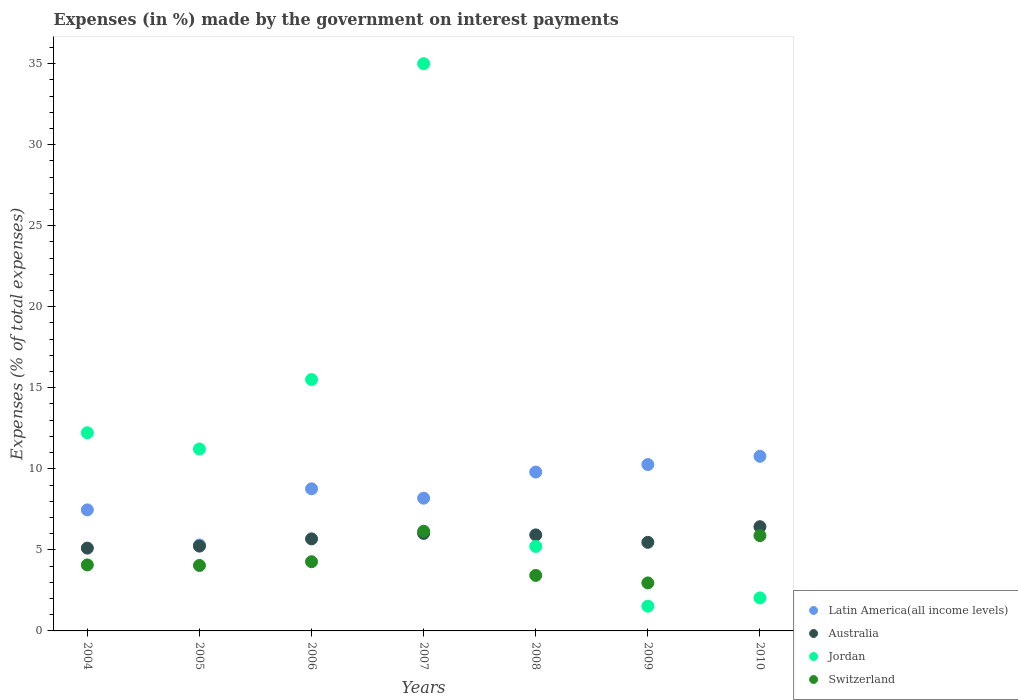How many different coloured dotlines are there?
Offer a very short reply. 4. What is the percentage of expenses made by the government on interest payments in Jordan in 2005?
Ensure brevity in your answer.  11.22. Across all years, what is the maximum percentage of expenses made by the government on interest payments in Switzerland?
Provide a short and direct response. 6.15. Across all years, what is the minimum percentage of expenses made by the government on interest payments in Jordan?
Your response must be concise. 1.52. In which year was the percentage of expenses made by the government on interest payments in Latin America(all income levels) maximum?
Your response must be concise. 2010. In which year was the percentage of expenses made by the government on interest payments in Latin America(all income levels) minimum?
Make the answer very short. 2005. What is the total percentage of expenses made by the government on interest payments in Switzerland in the graph?
Ensure brevity in your answer.  30.79. What is the difference between the percentage of expenses made by the government on interest payments in Switzerland in 2009 and that in 2010?
Your response must be concise. -2.92. What is the difference between the percentage of expenses made by the government on interest payments in Jordan in 2005 and the percentage of expenses made by the government on interest payments in Australia in 2009?
Your answer should be compact. 5.76. What is the average percentage of expenses made by the government on interest payments in Jordan per year?
Keep it short and to the point. 11.82. In the year 2010, what is the difference between the percentage of expenses made by the government on interest payments in Latin America(all income levels) and percentage of expenses made by the government on interest payments in Australia?
Give a very brief answer. 4.34. In how many years, is the percentage of expenses made by the government on interest payments in Australia greater than 7 %?
Give a very brief answer. 0. What is the ratio of the percentage of expenses made by the government on interest payments in Latin America(all income levels) in 2007 to that in 2008?
Offer a terse response. 0.84. Is the percentage of expenses made by the government on interest payments in Jordan in 2006 less than that in 2007?
Ensure brevity in your answer.  Yes. What is the difference between the highest and the second highest percentage of expenses made by the government on interest payments in Latin America(all income levels)?
Offer a terse response. 0.51. What is the difference between the highest and the lowest percentage of expenses made by the government on interest payments in Australia?
Give a very brief answer. 1.32. Is it the case that in every year, the sum of the percentage of expenses made by the government on interest payments in Jordan and percentage of expenses made by the government on interest payments in Switzerland  is greater than the sum of percentage of expenses made by the government on interest payments in Australia and percentage of expenses made by the government on interest payments in Latin America(all income levels)?
Give a very brief answer. No. Is the percentage of expenses made by the government on interest payments in Switzerland strictly greater than the percentage of expenses made by the government on interest payments in Australia over the years?
Keep it short and to the point. No. How many dotlines are there?
Your answer should be compact. 4. What is the difference between two consecutive major ticks on the Y-axis?
Your answer should be very brief. 5. Does the graph contain any zero values?
Keep it short and to the point. No. Does the graph contain grids?
Keep it short and to the point. No. How many legend labels are there?
Offer a terse response. 4. What is the title of the graph?
Give a very brief answer. Expenses (in %) made by the government on interest payments. Does "Lebanon" appear as one of the legend labels in the graph?
Keep it short and to the point. No. What is the label or title of the Y-axis?
Offer a terse response. Expenses (% of total expenses). What is the Expenses (% of total expenses) of Latin America(all income levels) in 2004?
Ensure brevity in your answer.  7.47. What is the Expenses (% of total expenses) of Australia in 2004?
Keep it short and to the point. 5.11. What is the Expenses (% of total expenses) of Jordan in 2004?
Provide a short and direct response. 12.22. What is the Expenses (% of total expenses) in Switzerland in 2004?
Give a very brief answer. 4.07. What is the Expenses (% of total expenses) in Latin America(all income levels) in 2005?
Keep it short and to the point. 5.3. What is the Expenses (% of total expenses) of Australia in 2005?
Your answer should be very brief. 5.23. What is the Expenses (% of total expenses) of Jordan in 2005?
Offer a very short reply. 11.22. What is the Expenses (% of total expenses) in Switzerland in 2005?
Offer a terse response. 4.04. What is the Expenses (% of total expenses) in Latin America(all income levels) in 2006?
Your answer should be compact. 8.77. What is the Expenses (% of total expenses) in Australia in 2006?
Offer a terse response. 5.68. What is the Expenses (% of total expenses) in Jordan in 2006?
Your response must be concise. 15.51. What is the Expenses (% of total expenses) of Switzerland in 2006?
Provide a short and direct response. 4.27. What is the Expenses (% of total expenses) in Latin America(all income levels) in 2007?
Provide a succinct answer. 8.19. What is the Expenses (% of total expenses) of Australia in 2007?
Ensure brevity in your answer.  6.02. What is the Expenses (% of total expenses) in Jordan in 2007?
Your answer should be compact. 34.99. What is the Expenses (% of total expenses) of Switzerland in 2007?
Provide a short and direct response. 6.15. What is the Expenses (% of total expenses) of Latin America(all income levels) in 2008?
Offer a terse response. 9.8. What is the Expenses (% of total expenses) in Australia in 2008?
Give a very brief answer. 5.92. What is the Expenses (% of total expenses) of Jordan in 2008?
Give a very brief answer. 5.21. What is the Expenses (% of total expenses) in Switzerland in 2008?
Your answer should be very brief. 3.42. What is the Expenses (% of total expenses) of Latin America(all income levels) in 2009?
Your response must be concise. 10.26. What is the Expenses (% of total expenses) of Australia in 2009?
Your response must be concise. 5.47. What is the Expenses (% of total expenses) in Jordan in 2009?
Your response must be concise. 1.52. What is the Expenses (% of total expenses) in Switzerland in 2009?
Offer a terse response. 2.96. What is the Expenses (% of total expenses) of Latin America(all income levels) in 2010?
Provide a short and direct response. 10.77. What is the Expenses (% of total expenses) in Australia in 2010?
Keep it short and to the point. 6.43. What is the Expenses (% of total expenses) in Jordan in 2010?
Your answer should be very brief. 2.04. What is the Expenses (% of total expenses) of Switzerland in 2010?
Give a very brief answer. 5.88. Across all years, what is the maximum Expenses (% of total expenses) in Latin America(all income levels)?
Keep it short and to the point. 10.77. Across all years, what is the maximum Expenses (% of total expenses) of Australia?
Your answer should be very brief. 6.43. Across all years, what is the maximum Expenses (% of total expenses) of Jordan?
Your response must be concise. 34.99. Across all years, what is the maximum Expenses (% of total expenses) in Switzerland?
Give a very brief answer. 6.15. Across all years, what is the minimum Expenses (% of total expenses) of Latin America(all income levels)?
Provide a succinct answer. 5.3. Across all years, what is the minimum Expenses (% of total expenses) in Australia?
Make the answer very short. 5.11. Across all years, what is the minimum Expenses (% of total expenses) of Jordan?
Offer a very short reply. 1.52. Across all years, what is the minimum Expenses (% of total expenses) of Switzerland?
Give a very brief answer. 2.96. What is the total Expenses (% of total expenses) of Latin America(all income levels) in the graph?
Make the answer very short. 60.56. What is the total Expenses (% of total expenses) of Australia in the graph?
Offer a very short reply. 39.86. What is the total Expenses (% of total expenses) of Jordan in the graph?
Offer a terse response. 82.73. What is the total Expenses (% of total expenses) in Switzerland in the graph?
Offer a terse response. 30.79. What is the difference between the Expenses (% of total expenses) in Latin America(all income levels) in 2004 and that in 2005?
Give a very brief answer. 2.17. What is the difference between the Expenses (% of total expenses) in Australia in 2004 and that in 2005?
Provide a short and direct response. -0.12. What is the difference between the Expenses (% of total expenses) of Jordan in 2004 and that in 2005?
Give a very brief answer. 1. What is the difference between the Expenses (% of total expenses) of Switzerland in 2004 and that in 2005?
Provide a short and direct response. 0.03. What is the difference between the Expenses (% of total expenses) of Latin America(all income levels) in 2004 and that in 2006?
Your answer should be compact. -1.3. What is the difference between the Expenses (% of total expenses) in Australia in 2004 and that in 2006?
Give a very brief answer. -0.57. What is the difference between the Expenses (% of total expenses) in Jordan in 2004 and that in 2006?
Offer a terse response. -3.28. What is the difference between the Expenses (% of total expenses) in Switzerland in 2004 and that in 2006?
Provide a short and direct response. -0.2. What is the difference between the Expenses (% of total expenses) of Latin America(all income levels) in 2004 and that in 2007?
Your response must be concise. -0.72. What is the difference between the Expenses (% of total expenses) in Australia in 2004 and that in 2007?
Your answer should be very brief. -0.91. What is the difference between the Expenses (% of total expenses) of Jordan in 2004 and that in 2007?
Provide a succinct answer. -22.77. What is the difference between the Expenses (% of total expenses) of Switzerland in 2004 and that in 2007?
Give a very brief answer. -2.08. What is the difference between the Expenses (% of total expenses) of Latin America(all income levels) in 2004 and that in 2008?
Give a very brief answer. -2.33. What is the difference between the Expenses (% of total expenses) of Australia in 2004 and that in 2008?
Your response must be concise. -0.81. What is the difference between the Expenses (% of total expenses) of Jordan in 2004 and that in 2008?
Your answer should be compact. 7.01. What is the difference between the Expenses (% of total expenses) of Switzerland in 2004 and that in 2008?
Ensure brevity in your answer.  0.65. What is the difference between the Expenses (% of total expenses) in Latin America(all income levels) in 2004 and that in 2009?
Your answer should be compact. -2.8. What is the difference between the Expenses (% of total expenses) in Australia in 2004 and that in 2009?
Offer a very short reply. -0.36. What is the difference between the Expenses (% of total expenses) in Switzerland in 2004 and that in 2009?
Your answer should be compact. 1.11. What is the difference between the Expenses (% of total expenses) in Latin America(all income levels) in 2004 and that in 2010?
Ensure brevity in your answer.  -3.3. What is the difference between the Expenses (% of total expenses) of Australia in 2004 and that in 2010?
Give a very brief answer. -1.32. What is the difference between the Expenses (% of total expenses) of Jordan in 2004 and that in 2010?
Ensure brevity in your answer.  10.19. What is the difference between the Expenses (% of total expenses) in Switzerland in 2004 and that in 2010?
Give a very brief answer. -1.81. What is the difference between the Expenses (% of total expenses) of Latin America(all income levels) in 2005 and that in 2006?
Give a very brief answer. -3.47. What is the difference between the Expenses (% of total expenses) of Australia in 2005 and that in 2006?
Provide a short and direct response. -0.45. What is the difference between the Expenses (% of total expenses) in Jordan in 2005 and that in 2006?
Keep it short and to the point. -4.28. What is the difference between the Expenses (% of total expenses) of Switzerland in 2005 and that in 2006?
Give a very brief answer. -0.23. What is the difference between the Expenses (% of total expenses) of Latin America(all income levels) in 2005 and that in 2007?
Provide a short and direct response. -2.89. What is the difference between the Expenses (% of total expenses) in Australia in 2005 and that in 2007?
Keep it short and to the point. -0.78. What is the difference between the Expenses (% of total expenses) of Jordan in 2005 and that in 2007?
Your response must be concise. -23.77. What is the difference between the Expenses (% of total expenses) in Switzerland in 2005 and that in 2007?
Offer a very short reply. -2.11. What is the difference between the Expenses (% of total expenses) of Latin America(all income levels) in 2005 and that in 2008?
Ensure brevity in your answer.  -4.5. What is the difference between the Expenses (% of total expenses) of Australia in 2005 and that in 2008?
Give a very brief answer. -0.69. What is the difference between the Expenses (% of total expenses) of Jordan in 2005 and that in 2008?
Provide a succinct answer. 6.01. What is the difference between the Expenses (% of total expenses) of Switzerland in 2005 and that in 2008?
Give a very brief answer. 0.61. What is the difference between the Expenses (% of total expenses) of Latin America(all income levels) in 2005 and that in 2009?
Provide a short and direct response. -4.96. What is the difference between the Expenses (% of total expenses) in Australia in 2005 and that in 2009?
Ensure brevity in your answer.  -0.23. What is the difference between the Expenses (% of total expenses) in Jordan in 2005 and that in 2009?
Give a very brief answer. 9.7. What is the difference between the Expenses (% of total expenses) of Switzerland in 2005 and that in 2009?
Your answer should be compact. 1.08. What is the difference between the Expenses (% of total expenses) of Latin America(all income levels) in 2005 and that in 2010?
Keep it short and to the point. -5.47. What is the difference between the Expenses (% of total expenses) in Australia in 2005 and that in 2010?
Ensure brevity in your answer.  -1.2. What is the difference between the Expenses (% of total expenses) in Jordan in 2005 and that in 2010?
Give a very brief answer. 9.19. What is the difference between the Expenses (% of total expenses) of Switzerland in 2005 and that in 2010?
Make the answer very short. -1.84. What is the difference between the Expenses (% of total expenses) of Latin America(all income levels) in 2006 and that in 2007?
Your answer should be compact. 0.58. What is the difference between the Expenses (% of total expenses) of Australia in 2006 and that in 2007?
Keep it short and to the point. -0.34. What is the difference between the Expenses (% of total expenses) of Jordan in 2006 and that in 2007?
Provide a short and direct response. -19.49. What is the difference between the Expenses (% of total expenses) in Switzerland in 2006 and that in 2007?
Your answer should be compact. -1.88. What is the difference between the Expenses (% of total expenses) in Latin America(all income levels) in 2006 and that in 2008?
Provide a short and direct response. -1.03. What is the difference between the Expenses (% of total expenses) of Australia in 2006 and that in 2008?
Keep it short and to the point. -0.24. What is the difference between the Expenses (% of total expenses) of Jordan in 2006 and that in 2008?
Offer a very short reply. 10.29. What is the difference between the Expenses (% of total expenses) in Switzerland in 2006 and that in 2008?
Your answer should be very brief. 0.84. What is the difference between the Expenses (% of total expenses) in Latin America(all income levels) in 2006 and that in 2009?
Offer a very short reply. -1.5. What is the difference between the Expenses (% of total expenses) of Australia in 2006 and that in 2009?
Your answer should be very brief. 0.21. What is the difference between the Expenses (% of total expenses) in Jordan in 2006 and that in 2009?
Keep it short and to the point. 13.98. What is the difference between the Expenses (% of total expenses) of Switzerland in 2006 and that in 2009?
Give a very brief answer. 1.31. What is the difference between the Expenses (% of total expenses) in Latin America(all income levels) in 2006 and that in 2010?
Your answer should be very brief. -2. What is the difference between the Expenses (% of total expenses) in Australia in 2006 and that in 2010?
Ensure brevity in your answer.  -0.75. What is the difference between the Expenses (% of total expenses) of Jordan in 2006 and that in 2010?
Give a very brief answer. 13.47. What is the difference between the Expenses (% of total expenses) in Switzerland in 2006 and that in 2010?
Your response must be concise. -1.61. What is the difference between the Expenses (% of total expenses) of Latin America(all income levels) in 2007 and that in 2008?
Your answer should be compact. -1.61. What is the difference between the Expenses (% of total expenses) of Australia in 2007 and that in 2008?
Make the answer very short. 0.09. What is the difference between the Expenses (% of total expenses) in Jordan in 2007 and that in 2008?
Provide a short and direct response. 29.78. What is the difference between the Expenses (% of total expenses) in Switzerland in 2007 and that in 2008?
Offer a terse response. 2.72. What is the difference between the Expenses (% of total expenses) of Latin America(all income levels) in 2007 and that in 2009?
Your response must be concise. -2.08. What is the difference between the Expenses (% of total expenses) in Australia in 2007 and that in 2009?
Offer a terse response. 0.55. What is the difference between the Expenses (% of total expenses) in Jordan in 2007 and that in 2009?
Ensure brevity in your answer.  33.47. What is the difference between the Expenses (% of total expenses) of Switzerland in 2007 and that in 2009?
Your response must be concise. 3.19. What is the difference between the Expenses (% of total expenses) in Latin America(all income levels) in 2007 and that in 2010?
Give a very brief answer. -2.58. What is the difference between the Expenses (% of total expenses) in Australia in 2007 and that in 2010?
Make the answer very short. -0.41. What is the difference between the Expenses (% of total expenses) of Jordan in 2007 and that in 2010?
Your response must be concise. 32.96. What is the difference between the Expenses (% of total expenses) in Switzerland in 2007 and that in 2010?
Give a very brief answer. 0.27. What is the difference between the Expenses (% of total expenses) in Latin America(all income levels) in 2008 and that in 2009?
Ensure brevity in your answer.  -0.46. What is the difference between the Expenses (% of total expenses) in Australia in 2008 and that in 2009?
Your answer should be compact. 0.46. What is the difference between the Expenses (% of total expenses) in Jordan in 2008 and that in 2009?
Offer a terse response. 3.69. What is the difference between the Expenses (% of total expenses) in Switzerland in 2008 and that in 2009?
Ensure brevity in your answer.  0.46. What is the difference between the Expenses (% of total expenses) of Latin America(all income levels) in 2008 and that in 2010?
Provide a short and direct response. -0.97. What is the difference between the Expenses (% of total expenses) of Australia in 2008 and that in 2010?
Your answer should be very brief. -0.51. What is the difference between the Expenses (% of total expenses) of Jordan in 2008 and that in 2010?
Your response must be concise. 3.18. What is the difference between the Expenses (% of total expenses) of Switzerland in 2008 and that in 2010?
Provide a succinct answer. -2.46. What is the difference between the Expenses (% of total expenses) in Latin America(all income levels) in 2009 and that in 2010?
Provide a short and direct response. -0.51. What is the difference between the Expenses (% of total expenses) in Australia in 2009 and that in 2010?
Make the answer very short. -0.96. What is the difference between the Expenses (% of total expenses) of Jordan in 2009 and that in 2010?
Your response must be concise. -0.51. What is the difference between the Expenses (% of total expenses) of Switzerland in 2009 and that in 2010?
Provide a short and direct response. -2.92. What is the difference between the Expenses (% of total expenses) in Latin America(all income levels) in 2004 and the Expenses (% of total expenses) in Australia in 2005?
Your response must be concise. 2.24. What is the difference between the Expenses (% of total expenses) of Latin America(all income levels) in 2004 and the Expenses (% of total expenses) of Jordan in 2005?
Your response must be concise. -3.76. What is the difference between the Expenses (% of total expenses) in Latin America(all income levels) in 2004 and the Expenses (% of total expenses) in Switzerland in 2005?
Provide a succinct answer. 3.43. What is the difference between the Expenses (% of total expenses) of Australia in 2004 and the Expenses (% of total expenses) of Jordan in 2005?
Provide a succinct answer. -6.11. What is the difference between the Expenses (% of total expenses) of Australia in 2004 and the Expenses (% of total expenses) of Switzerland in 2005?
Give a very brief answer. 1.07. What is the difference between the Expenses (% of total expenses) in Jordan in 2004 and the Expenses (% of total expenses) in Switzerland in 2005?
Your response must be concise. 8.19. What is the difference between the Expenses (% of total expenses) in Latin America(all income levels) in 2004 and the Expenses (% of total expenses) in Australia in 2006?
Make the answer very short. 1.79. What is the difference between the Expenses (% of total expenses) in Latin America(all income levels) in 2004 and the Expenses (% of total expenses) in Jordan in 2006?
Ensure brevity in your answer.  -8.04. What is the difference between the Expenses (% of total expenses) of Latin America(all income levels) in 2004 and the Expenses (% of total expenses) of Switzerland in 2006?
Provide a succinct answer. 3.2. What is the difference between the Expenses (% of total expenses) in Australia in 2004 and the Expenses (% of total expenses) in Jordan in 2006?
Keep it short and to the point. -10.4. What is the difference between the Expenses (% of total expenses) of Australia in 2004 and the Expenses (% of total expenses) of Switzerland in 2006?
Offer a very short reply. 0.84. What is the difference between the Expenses (% of total expenses) in Jordan in 2004 and the Expenses (% of total expenses) in Switzerland in 2006?
Provide a short and direct response. 7.96. What is the difference between the Expenses (% of total expenses) of Latin America(all income levels) in 2004 and the Expenses (% of total expenses) of Australia in 2007?
Your answer should be compact. 1.45. What is the difference between the Expenses (% of total expenses) of Latin America(all income levels) in 2004 and the Expenses (% of total expenses) of Jordan in 2007?
Your response must be concise. -27.53. What is the difference between the Expenses (% of total expenses) in Latin America(all income levels) in 2004 and the Expenses (% of total expenses) in Switzerland in 2007?
Your answer should be very brief. 1.32. What is the difference between the Expenses (% of total expenses) of Australia in 2004 and the Expenses (% of total expenses) of Jordan in 2007?
Keep it short and to the point. -29.89. What is the difference between the Expenses (% of total expenses) in Australia in 2004 and the Expenses (% of total expenses) in Switzerland in 2007?
Your response must be concise. -1.04. What is the difference between the Expenses (% of total expenses) of Jordan in 2004 and the Expenses (% of total expenses) of Switzerland in 2007?
Make the answer very short. 6.08. What is the difference between the Expenses (% of total expenses) in Latin America(all income levels) in 2004 and the Expenses (% of total expenses) in Australia in 2008?
Offer a terse response. 1.54. What is the difference between the Expenses (% of total expenses) in Latin America(all income levels) in 2004 and the Expenses (% of total expenses) in Jordan in 2008?
Your response must be concise. 2.25. What is the difference between the Expenses (% of total expenses) of Latin America(all income levels) in 2004 and the Expenses (% of total expenses) of Switzerland in 2008?
Give a very brief answer. 4.04. What is the difference between the Expenses (% of total expenses) in Australia in 2004 and the Expenses (% of total expenses) in Jordan in 2008?
Your answer should be very brief. -0.1. What is the difference between the Expenses (% of total expenses) in Australia in 2004 and the Expenses (% of total expenses) in Switzerland in 2008?
Provide a short and direct response. 1.68. What is the difference between the Expenses (% of total expenses) in Jordan in 2004 and the Expenses (% of total expenses) in Switzerland in 2008?
Provide a succinct answer. 8.8. What is the difference between the Expenses (% of total expenses) of Latin America(all income levels) in 2004 and the Expenses (% of total expenses) of Australia in 2009?
Your response must be concise. 2. What is the difference between the Expenses (% of total expenses) in Latin America(all income levels) in 2004 and the Expenses (% of total expenses) in Jordan in 2009?
Keep it short and to the point. 5.94. What is the difference between the Expenses (% of total expenses) in Latin America(all income levels) in 2004 and the Expenses (% of total expenses) in Switzerland in 2009?
Your response must be concise. 4.51. What is the difference between the Expenses (% of total expenses) in Australia in 2004 and the Expenses (% of total expenses) in Jordan in 2009?
Ensure brevity in your answer.  3.58. What is the difference between the Expenses (% of total expenses) of Australia in 2004 and the Expenses (% of total expenses) of Switzerland in 2009?
Make the answer very short. 2.15. What is the difference between the Expenses (% of total expenses) of Jordan in 2004 and the Expenses (% of total expenses) of Switzerland in 2009?
Your answer should be very brief. 9.26. What is the difference between the Expenses (% of total expenses) of Latin America(all income levels) in 2004 and the Expenses (% of total expenses) of Australia in 2010?
Give a very brief answer. 1.04. What is the difference between the Expenses (% of total expenses) of Latin America(all income levels) in 2004 and the Expenses (% of total expenses) of Jordan in 2010?
Your response must be concise. 5.43. What is the difference between the Expenses (% of total expenses) in Latin America(all income levels) in 2004 and the Expenses (% of total expenses) in Switzerland in 2010?
Ensure brevity in your answer.  1.59. What is the difference between the Expenses (% of total expenses) in Australia in 2004 and the Expenses (% of total expenses) in Jordan in 2010?
Provide a succinct answer. 3.07. What is the difference between the Expenses (% of total expenses) of Australia in 2004 and the Expenses (% of total expenses) of Switzerland in 2010?
Give a very brief answer. -0.77. What is the difference between the Expenses (% of total expenses) of Jordan in 2004 and the Expenses (% of total expenses) of Switzerland in 2010?
Offer a very short reply. 6.34. What is the difference between the Expenses (% of total expenses) of Latin America(all income levels) in 2005 and the Expenses (% of total expenses) of Australia in 2006?
Your answer should be compact. -0.38. What is the difference between the Expenses (% of total expenses) in Latin America(all income levels) in 2005 and the Expenses (% of total expenses) in Jordan in 2006?
Offer a very short reply. -10.21. What is the difference between the Expenses (% of total expenses) of Latin America(all income levels) in 2005 and the Expenses (% of total expenses) of Switzerland in 2006?
Give a very brief answer. 1.03. What is the difference between the Expenses (% of total expenses) in Australia in 2005 and the Expenses (% of total expenses) in Jordan in 2006?
Your answer should be very brief. -10.28. What is the difference between the Expenses (% of total expenses) of Australia in 2005 and the Expenses (% of total expenses) of Switzerland in 2006?
Provide a short and direct response. 0.96. What is the difference between the Expenses (% of total expenses) in Jordan in 2005 and the Expenses (% of total expenses) in Switzerland in 2006?
Offer a very short reply. 6.95. What is the difference between the Expenses (% of total expenses) in Latin America(all income levels) in 2005 and the Expenses (% of total expenses) in Australia in 2007?
Offer a terse response. -0.72. What is the difference between the Expenses (% of total expenses) of Latin America(all income levels) in 2005 and the Expenses (% of total expenses) of Jordan in 2007?
Offer a terse response. -29.7. What is the difference between the Expenses (% of total expenses) of Latin America(all income levels) in 2005 and the Expenses (% of total expenses) of Switzerland in 2007?
Provide a short and direct response. -0.85. What is the difference between the Expenses (% of total expenses) of Australia in 2005 and the Expenses (% of total expenses) of Jordan in 2007?
Your answer should be compact. -29.76. What is the difference between the Expenses (% of total expenses) in Australia in 2005 and the Expenses (% of total expenses) in Switzerland in 2007?
Offer a terse response. -0.91. What is the difference between the Expenses (% of total expenses) in Jordan in 2005 and the Expenses (% of total expenses) in Switzerland in 2007?
Offer a very short reply. 5.08. What is the difference between the Expenses (% of total expenses) of Latin America(all income levels) in 2005 and the Expenses (% of total expenses) of Australia in 2008?
Provide a short and direct response. -0.62. What is the difference between the Expenses (% of total expenses) in Latin America(all income levels) in 2005 and the Expenses (% of total expenses) in Jordan in 2008?
Your response must be concise. 0.09. What is the difference between the Expenses (% of total expenses) of Latin America(all income levels) in 2005 and the Expenses (% of total expenses) of Switzerland in 2008?
Provide a short and direct response. 1.88. What is the difference between the Expenses (% of total expenses) of Australia in 2005 and the Expenses (% of total expenses) of Jordan in 2008?
Provide a short and direct response. 0.02. What is the difference between the Expenses (% of total expenses) of Australia in 2005 and the Expenses (% of total expenses) of Switzerland in 2008?
Your response must be concise. 1.81. What is the difference between the Expenses (% of total expenses) in Jordan in 2005 and the Expenses (% of total expenses) in Switzerland in 2008?
Ensure brevity in your answer.  7.8. What is the difference between the Expenses (% of total expenses) in Latin America(all income levels) in 2005 and the Expenses (% of total expenses) in Australia in 2009?
Your response must be concise. -0.17. What is the difference between the Expenses (% of total expenses) in Latin America(all income levels) in 2005 and the Expenses (% of total expenses) in Jordan in 2009?
Provide a succinct answer. 3.78. What is the difference between the Expenses (% of total expenses) in Latin America(all income levels) in 2005 and the Expenses (% of total expenses) in Switzerland in 2009?
Ensure brevity in your answer.  2.34. What is the difference between the Expenses (% of total expenses) of Australia in 2005 and the Expenses (% of total expenses) of Jordan in 2009?
Your answer should be very brief. 3.71. What is the difference between the Expenses (% of total expenses) of Australia in 2005 and the Expenses (% of total expenses) of Switzerland in 2009?
Make the answer very short. 2.27. What is the difference between the Expenses (% of total expenses) in Jordan in 2005 and the Expenses (% of total expenses) in Switzerland in 2009?
Provide a short and direct response. 8.26. What is the difference between the Expenses (% of total expenses) in Latin America(all income levels) in 2005 and the Expenses (% of total expenses) in Australia in 2010?
Offer a very short reply. -1.13. What is the difference between the Expenses (% of total expenses) in Latin America(all income levels) in 2005 and the Expenses (% of total expenses) in Jordan in 2010?
Offer a terse response. 3.26. What is the difference between the Expenses (% of total expenses) in Latin America(all income levels) in 2005 and the Expenses (% of total expenses) in Switzerland in 2010?
Keep it short and to the point. -0.58. What is the difference between the Expenses (% of total expenses) of Australia in 2005 and the Expenses (% of total expenses) of Jordan in 2010?
Keep it short and to the point. 3.2. What is the difference between the Expenses (% of total expenses) of Australia in 2005 and the Expenses (% of total expenses) of Switzerland in 2010?
Provide a short and direct response. -0.65. What is the difference between the Expenses (% of total expenses) in Jordan in 2005 and the Expenses (% of total expenses) in Switzerland in 2010?
Your response must be concise. 5.34. What is the difference between the Expenses (% of total expenses) in Latin America(all income levels) in 2006 and the Expenses (% of total expenses) in Australia in 2007?
Ensure brevity in your answer.  2.75. What is the difference between the Expenses (% of total expenses) in Latin America(all income levels) in 2006 and the Expenses (% of total expenses) in Jordan in 2007?
Provide a succinct answer. -26.23. What is the difference between the Expenses (% of total expenses) of Latin America(all income levels) in 2006 and the Expenses (% of total expenses) of Switzerland in 2007?
Your answer should be very brief. 2.62. What is the difference between the Expenses (% of total expenses) in Australia in 2006 and the Expenses (% of total expenses) in Jordan in 2007?
Your answer should be compact. -29.32. What is the difference between the Expenses (% of total expenses) in Australia in 2006 and the Expenses (% of total expenses) in Switzerland in 2007?
Offer a terse response. -0.47. What is the difference between the Expenses (% of total expenses) in Jordan in 2006 and the Expenses (% of total expenses) in Switzerland in 2007?
Keep it short and to the point. 9.36. What is the difference between the Expenses (% of total expenses) in Latin America(all income levels) in 2006 and the Expenses (% of total expenses) in Australia in 2008?
Your response must be concise. 2.84. What is the difference between the Expenses (% of total expenses) of Latin America(all income levels) in 2006 and the Expenses (% of total expenses) of Jordan in 2008?
Offer a very short reply. 3.55. What is the difference between the Expenses (% of total expenses) of Latin America(all income levels) in 2006 and the Expenses (% of total expenses) of Switzerland in 2008?
Ensure brevity in your answer.  5.34. What is the difference between the Expenses (% of total expenses) in Australia in 2006 and the Expenses (% of total expenses) in Jordan in 2008?
Provide a succinct answer. 0.47. What is the difference between the Expenses (% of total expenses) in Australia in 2006 and the Expenses (% of total expenses) in Switzerland in 2008?
Provide a short and direct response. 2.25. What is the difference between the Expenses (% of total expenses) in Jordan in 2006 and the Expenses (% of total expenses) in Switzerland in 2008?
Provide a succinct answer. 12.08. What is the difference between the Expenses (% of total expenses) of Latin America(all income levels) in 2006 and the Expenses (% of total expenses) of Australia in 2009?
Your response must be concise. 3.3. What is the difference between the Expenses (% of total expenses) in Latin America(all income levels) in 2006 and the Expenses (% of total expenses) in Jordan in 2009?
Offer a terse response. 7.24. What is the difference between the Expenses (% of total expenses) of Latin America(all income levels) in 2006 and the Expenses (% of total expenses) of Switzerland in 2009?
Keep it short and to the point. 5.81. What is the difference between the Expenses (% of total expenses) of Australia in 2006 and the Expenses (% of total expenses) of Jordan in 2009?
Provide a succinct answer. 4.15. What is the difference between the Expenses (% of total expenses) of Australia in 2006 and the Expenses (% of total expenses) of Switzerland in 2009?
Your response must be concise. 2.72. What is the difference between the Expenses (% of total expenses) in Jordan in 2006 and the Expenses (% of total expenses) in Switzerland in 2009?
Make the answer very short. 12.55. What is the difference between the Expenses (% of total expenses) in Latin America(all income levels) in 2006 and the Expenses (% of total expenses) in Australia in 2010?
Your answer should be very brief. 2.34. What is the difference between the Expenses (% of total expenses) of Latin America(all income levels) in 2006 and the Expenses (% of total expenses) of Jordan in 2010?
Keep it short and to the point. 6.73. What is the difference between the Expenses (% of total expenses) in Latin America(all income levels) in 2006 and the Expenses (% of total expenses) in Switzerland in 2010?
Provide a short and direct response. 2.89. What is the difference between the Expenses (% of total expenses) of Australia in 2006 and the Expenses (% of total expenses) of Jordan in 2010?
Give a very brief answer. 3.64. What is the difference between the Expenses (% of total expenses) of Australia in 2006 and the Expenses (% of total expenses) of Switzerland in 2010?
Provide a short and direct response. -0.2. What is the difference between the Expenses (% of total expenses) of Jordan in 2006 and the Expenses (% of total expenses) of Switzerland in 2010?
Your answer should be very brief. 9.63. What is the difference between the Expenses (% of total expenses) in Latin America(all income levels) in 2007 and the Expenses (% of total expenses) in Australia in 2008?
Give a very brief answer. 2.27. What is the difference between the Expenses (% of total expenses) of Latin America(all income levels) in 2007 and the Expenses (% of total expenses) of Jordan in 2008?
Your answer should be compact. 2.98. What is the difference between the Expenses (% of total expenses) in Latin America(all income levels) in 2007 and the Expenses (% of total expenses) in Switzerland in 2008?
Offer a very short reply. 4.76. What is the difference between the Expenses (% of total expenses) of Australia in 2007 and the Expenses (% of total expenses) of Jordan in 2008?
Make the answer very short. 0.8. What is the difference between the Expenses (% of total expenses) in Australia in 2007 and the Expenses (% of total expenses) in Switzerland in 2008?
Offer a very short reply. 2.59. What is the difference between the Expenses (% of total expenses) of Jordan in 2007 and the Expenses (% of total expenses) of Switzerland in 2008?
Your response must be concise. 31.57. What is the difference between the Expenses (% of total expenses) of Latin America(all income levels) in 2007 and the Expenses (% of total expenses) of Australia in 2009?
Give a very brief answer. 2.72. What is the difference between the Expenses (% of total expenses) of Latin America(all income levels) in 2007 and the Expenses (% of total expenses) of Jordan in 2009?
Your response must be concise. 6.66. What is the difference between the Expenses (% of total expenses) in Latin America(all income levels) in 2007 and the Expenses (% of total expenses) in Switzerland in 2009?
Keep it short and to the point. 5.23. What is the difference between the Expenses (% of total expenses) of Australia in 2007 and the Expenses (% of total expenses) of Jordan in 2009?
Your answer should be very brief. 4.49. What is the difference between the Expenses (% of total expenses) in Australia in 2007 and the Expenses (% of total expenses) in Switzerland in 2009?
Make the answer very short. 3.05. What is the difference between the Expenses (% of total expenses) of Jordan in 2007 and the Expenses (% of total expenses) of Switzerland in 2009?
Your answer should be compact. 32.03. What is the difference between the Expenses (% of total expenses) of Latin America(all income levels) in 2007 and the Expenses (% of total expenses) of Australia in 2010?
Provide a short and direct response. 1.76. What is the difference between the Expenses (% of total expenses) in Latin America(all income levels) in 2007 and the Expenses (% of total expenses) in Jordan in 2010?
Provide a short and direct response. 6.15. What is the difference between the Expenses (% of total expenses) of Latin America(all income levels) in 2007 and the Expenses (% of total expenses) of Switzerland in 2010?
Your answer should be very brief. 2.31. What is the difference between the Expenses (% of total expenses) of Australia in 2007 and the Expenses (% of total expenses) of Jordan in 2010?
Your answer should be compact. 3.98. What is the difference between the Expenses (% of total expenses) in Australia in 2007 and the Expenses (% of total expenses) in Switzerland in 2010?
Your answer should be compact. 0.14. What is the difference between the Expenses (% of total expenses) of Jordan in 2007 and the Expenses (% of total expenses) of Switzerland in 2010?
Provide a short and direct response. 29.11. What is the difference between the Expenses (% of total expenses) of Latin America(all income levels) in 2008 and the Expenses (% of total expenses) of Australia in 2009?
Ensure brevity in your answer.  4.34. What is the difference between the Expenses (% of total expenses) of Latin America(all income levels) in 2008 and the Expenses (% of total expenses) of Jordan in 2009?
Provide a succinct answer. 8.28. What is the difference between the Expenses (% of total expenses) in Latin America(all income levels) in 2008 and the Expenses (% of total expenses) in Switzerland in 2009?
Offer a very short reply. 6.84. What is the difference between the Expenses (% of total expenses) in Australia in 2008 and the Expenses (% of total expenses) in Jordan in 2009?
Provide a succinct answer. 4.4. What is the difference between the Expenses (% of total expenses) in Australia in 2008 and the Expenses (% of total expenses) in Switzerland in 2009?
Ensure brevity in your answer.  2.96. What is the difference between the Expenses (% of total expenses) of Jordan in 2008 and the Expenses (% of total expenses) of Switzerland in 2009?
Offer a terse response. 2.25. What is the difference between the Expenses (% of total expenses) in Latin America(all income levels) in 2008 and the Expenses (% of total expenses) in Australia in 2010?
Ensure brevity in your answer.  3.37. What is the difference between the Expenses (% of total expenses) in Latin America(all income levels) in 2008 and the Expenses (% of total expenses) in Jordan in 2010?
Give a very brief answer. 7.76. What is the difference between the Expenses (% of total expenses) of Latin America(all income levels) in 2008 and the Expenses (% of total expenses) of Switzerland in 2010?
Give a very brief answer. 3.92. What is the difference between the Expenses (% of total expenses) of Australia in 2008 and the Expenses (% of total expenses) of Jordan in 2010?
Your response must be concise. 3.89. What is the difference between the Expenses (% of total expenses) of Australia in 2008 and the Expenses (% of total expenses) of Switzerland in 2010?
Provide a succinct answer. 0.04. What is the difference between the Expenses (% of total expenses) in Jordan in 2008 and the Expenses (% of total expenses) in Switzerland in 2010?
Give a very brief answer. -0.67. What is the difference between the Expenses (% of total expenses) in Latin America(all income levels) in 2009 and the Expenses (% of total expenses) in Australia in 2010?
Provide a short and direct response. 3.84. What is the difference between the Expenses (% of total expenses) in Latin America(all income levels) in 2009 and the Expenses (% of total expenses) in Jordan in 2010?
Make the answer very short. 8.23. What is the difference between the Expenses (% of total expenses) of Latin America(all income levels) in 2009 and the Expenses (% of total expenses) of Switzerland in 2010?
Offer a very short reply. 4.38. What is the difference between the Expenses (% of total expenses) of Australia in 2009 and the Expenses (% of total expenses) of Jordan in 2010?
Provide a succinct answer. 3.43. What is the difference between the Expenses (% of total expenses) of Australia in 2009 and the Expenses (% of total expenses) of Switzerland in 2010?
Ensure brevity in your answer.  -0.42. What is the difference between the Expenses (% of total expenses) of Jordan in 2009 and the Expenses (% of total expenses) of Switzerland in 2010?
Provide a succinct answer. -4.36. What is the average Expenses (% of total expenses) of Latin America(all income levels) per year?
Your answer should be compact. 8.65. What is the average Expenses (% of total expenses) of Australia per year?
Provide a short and direct response. 5.69. What is the average Expenses (% of total expenses) of Jordan per year?
Provide a succinct answer. 11.82. What is the average Expenses (% of total expenses) in Switzerland per year?
Your answer should be very brief. 4.4. In the year 2004, what is the difference between the Expenses (% of total expenses) of Latin America(all income levels) and Expenses (% of total expenses) of Australia?
Your answer should be compact. 2.36. In the year 2004, what is the difference between the Expenses (% of total expenses) of Latin America(all income levels) and Expenses (% of total expenses) of Jordan?
Ensure brevity in your answer.  -4.76. In the year 2004, what is the difference between the Expenses (% of total expenses) in Latin America(all income levels) and Expenses (% of total expenses) in Switzerland?
Offer a very short reply. 3.4. In the year 2004, what is the difference between the Expenses (% of total expenses) in Australia and Expenses (% of total expenses) in Jordan?
Provide a short and direct response. -7.12. In the year 2004, what is the difference between the Expenses (% of total expenses) of Australia and Expenses (% of total expenses) of Switzerland?
Offer a terse response. 1.04. In the year 2004, what is the difference between the Expenses (% of total expenses) in Jordan and Expenses (% of total expenses) in Switzerland?
Your answer should be compact. 8.15. In the year 2005, what is the difference between the Expenses (% of total expenses) in Latin America(all income levels) and Expenses (% of total expenses) in Australia?
Your response must be concise. 0.07. In the year 2005, what is the difference between the Expenses (% of total expenses) in Latin America(all income levels) and Expenses (% of total expenses) in Jordan?
Offer a terse response. -5.92. In the year 2005, what is the difference between the Expenses (% of total expenses) of Latin America(all income levels) and Expenses (% of total expenses) of Switzerland?
Ensure brevity in your answer.  1.26. In the year 2005, what is the difference between the Expenses (% of total expenses) of Australia and Expenses (% of total expenses) of Jordan?
Keep it short and to the point. -5.99. In the year 2005, what is the difference between the Expenses (% of total expenses) in Australia and Expenses (% of total expenses) in Switzerland?
Provide a succinct answer. 1.19. In the year 2005, what is the difference between the Expenses (% of total expenses) in Jordan and Expenses (% of total expenses) in Switzerland?
Your answer should be compact. 7.18. In the year 2006, what is the difference between the Expenses (% of total expenses) in Latin America(all income levels) and Expenses (% of total expenses) in Australia?
Keep it short and to the point. 3.09. In the year 2006, what is the difference between the Expenses (% of total expenses) in Latin America(all income levels) and Expenses (% of total expenses) in Jordan?
Give a very brief answer. -6.74. In the year 2006, what is the difference between the Expenses (% of total expenses) in Latin America(all income levels) and Expenses (% of total expenses) in Switzerland?
Keep it short and to the point. 4.5. In the year 2006, what is the difference between the Expenses (% of total expenses) of Australia and Expenses (% of total expenses) of Jordan?
Give a very brief answer. -9.83. In the year 2006, what is the difference between the Expenses (% of total expenses) in Australia and Expenses (% of total expenses) in Switzerland?
Your answer should be compact. 1.41. In the year 2006, what is the difference between the Expenses (% of total expenses) in Jordan and Expenses (% of total expenses) in Switzerland?
Provide a short and direct response. 11.24. In the year 2007, what is the difference between the Expenses (% of total expenses) of Latin America(all income levels) and Expenses (% of total expenses) of Australia?
Give a very brief answer. 2.17. In the year 2007, what is the difference between the Expenses (% of total expenses) in Latin America(all income levels) and Expenses (% of total expenses) in Jordan?
Offer a very short reply. -26.81. In the year 2007, what is the difference between the Expenses (% of total expenses) in Latin America(all income levels) and Expenses (% of total expenses) in Switzerland?
Give a very brief answer. 2.04. In the year 2007, what is the difference between the Expenses (% of total expenses) of Australia and Expenses (% of total expenses) of Jordan?
Ensure brevity in your answer.  -28.98. In the year 2007, what is the difference between the Expenses (% of total expenses) of Australia and Expenses (% of total expenses) of Switzerland?
Offer a very short reply. -0.13. In the year 2007, what is the difference between the Expenses (% of total expenses) of Jordan and Expenses (% of total expenses) of Switzerland?
Your answer should be compact. 28.85. In the year 2008, what is the difference between the Expenses (% of total expenses) of Latin America(all income levels) and Expenses (% of total expenses) of Australia?
Make the answer very short. 3.88. In the year 2008, what is the difference between the Expenses (% of total expenses) of Latin America(all income levels) and Expenses (% of total expenses) of Jordan?
Your answer should be compact. 4.59. In the year 2008, what is the difference between the Expenses (% of total expenses) in Latin America(all income levels) and Expenses (% of total expenses) in Switzerland?
Your answer should be compact. 6.38. In the year 2008, what is the difference between the Expenses (% of total expenses) in Australia and Expenses (% of total expenses) in Jordan?
Give a very brief answer. 0.71. In the year 2008, what is the difference between the Expenses (% of total expenses) of Australia and Expenses (% of total expenses) of Switzerland?
Your answer should be compact. 2.5. In the year 2008, what is the difference between the Expenses (% of total expenses) in Jordan and Expenses (% of total expenses) in Switzerland?
Your answer should be very brief. 1.79. In the year 2009, what is the difference between the Expenses (% of total expenses) of Latin America(all income levels) and Expenses (% of total expenses) of Australia?
Provide a short and direct response. 4.8. In the year 2009, what is the difference between the Expenses (% of total expenses) of Latin America(all income levels) and Expenses (% of total expenses) of Jordan?
Give a very brief answer. 8.74. In the year 2009, what is the difference between the Expenses (% of total expenses) of Latin America(all income levels) and Expenses (% of total expenses) of Switzerland?
Ensure brevity in your answer.  7.3. In the year 2009, what is the difference between the Expenses (% of total expenses) in Australia and Expenses (% of total expenses) in Jordan?
Provide a succinct answer. 3.94. In the year 2009, what is the difference between the Expenses (% of total expenses) of Australia and Expenses (% of total expenses) of Switzerland?
Your answer should be compact. 2.5. In the year 2009, what is the difference between the Expenses (% of total expenses) of Jordan and Expenses (% of total expenses) of Switzerland?
Make the answer very short. -1.44. In the year 2010, what is the difference between the Expenses (% of total expenses) in Latin America(all income levels) and Expenses (% of total expenses) in Australia?
Your answer should be very brief. 4.34. In the year 2010, what is the difference between the Expenses (% of total expenses) in Latin America(all income levels) and Expenses (% of total expenses) in Jordan?
Make the answer very short. 8.74. In the year 2010, what is the difference between the Expenses (% of total expenses) in Latin America(all income levels) and Expenses (% of total expenses) in Switzerland?
Ensure brevity in your answer.  4.89. In the year 2010, what is the difference between the Expenses (% of total expenses) of Australia and Expenses (% of total expenses) of Jordan?
Offer a very short reply. 4.39. In the year 2010, what is the difference between the Expenses (% of total expenses) in Australia and Expenses (% of total expenses) in Switzerland?
Ensure brevity in your answer.  0.55. In the year 2010, what is the difference between the Expenses (% of total expenses) of Jordan and Expenses (% of total expenses) of Switzerland?
Provide a succinct answer. -3.84. What is the ratio of the Expenses (% of total expenses) of Latin America(all income levels) in 2004 to that in 2005?
Offer a terse response. 1.41. What is the ratio of the Expenses (% of total expenses) in Australia in 2004 to that in 2005?
Keep it short and to the point. 0.98. What is the ratio of the Expenses (% of total expenses) in Jordan in 2004 to that in 2005?
Your answer should be compact. 1.09. What is the ratio of the Expenses (% of total expenses) in Switzerland in 2004 to that in 2005?
Provide a short and direct response. 1.01. What is the ratio of the Expenses (% of total expenses) of Latin America(all income levels) in 2004 to that in 2006?
Offer a very short reply. 0.85. What is the ratio of the Expenses (% of total expenses) in Australia in 2004 to that in 2006?
Make the answer very short. 0.9. What is the ratio of the Expenses (% of total expenses) of Jordan in 2004 to that in 2006?
Ensure brevity in your answer.  0.79. What is the ratio of the Expenses (% of total expenses) in Switzerland in 2004 to that in 2006?
Keep it short and to the point. 0.95. What is the ratio of the Expenses (% of total expenses) in Latin America(all income levels) in 2004 to that in 2007?
Provide a succinct answer. 0.91. What is the ratio of the Expenses (% of total expenses) in Australia in 2004 to that in 2007?
Offer a very short reply. 0.85. What is the ratio of the Expenses (% of total expenses) in Jordan in 2004 to that in 2007?
Give a very brief answer. 0.35. What is the ratio of the Expenses (% of total expenses) in Switzerland in 2004 to that in 2007?
Keep it short and to the point. 0.66. What is the ratio of the Expenses (% of total expenses) in Latin America(all income levels) in 2004 to that in 2008?
Your answer should be compact. 0.76. What is the ratio of the Expenses (% of total expenses) in Australia in 2004 to that in 2008?
Offer a very short reply. 0.86. What is the ratio of the Expenses (% of total expenses) of Jordan in 2004 to that in 2008?
Keep it short and to the point. 2.35. What is the ratio of the Expenses (% of total expenses) in Switzerland in 2004 to that in 2008?
Your answer should be compact. 1.19. What is the ratio of the Expenses (% of total expenses) of Latin America(all income levels) in 2004 to that in 2009?
Your answer should be very brief. 0.73. What is the ratio of the Expenses (% of total expenses) in Australia in 2004 to that in 2009?
Provide a succinct answer. 0.93. What is the ratio of the Expenses (% of total expenses) in Jordan in 2004 to that in 2009?
Keep it short and to the point. 8.02. What is the ratio of the Expenses (% of total expenses) of Switzerland in 2004 to that in 2009?
Ensure brevity in your answer.  1.37. What is the ratio of the Expenses (% of total expenses) in Latin America(all income levels) in 2004 to that in 2010?
Offer a terse response. 0.69. What is the ratio of the Expenses (% of total expenses) of Australia in 2004 to that in 2010?
Offer a very short reply. 0.79. What is the ratio of the Expenses (% of total expenses) of Jordan in 2004 to that in 2010?
Provide a succinct answer. 6. What is the ratio of the Expenses (% of total expenses) of Switzerland in 2004 to that in 2010?
Keep it short and to the point. 0.69. What is the ratio of the Expenses (% of total expenses) of Latin America(all income levels) in 2005 to that in 2006?
Ensure brevity in your answer.  0.6. What is the ratio of the Expenses (% of total expenses) in Australia in 2005 to that in 2006?
Provide a succinct answer. 0.92. What is the ratio of the Expenses (% of total expenses) in Jordan in 2005 to that in 2006?
Ensure brevity in your answer.  0.72. What is the ratio of the Expenses (% of total expenses) of Switzerland in 2005 to that in 2006?
Provide a succinct answer. 0.95. What is the ratio of the Expenses (% of total expenses) of Latin America(all income levels) in 2005 to that in 2007?
Ensure brevity in your answer.  0.65. What is the ratio of the Expenses (% of total expenses) in Australia in 2005 to that in 2007?
Give a very brief answer. 0.87. What is the ratio of the Expenses (% of total expenses) of Jordan in 2005 to that in 2007?
Offer a terse response. 0.32. What is the ratio of the Expenses (% of total expenses) of Switzerland in 2005 to that in 2007?
Your answer should be compact. 0.66. What is the ratio of the Expenses (% of total expenses) of Latin America(all income levels) in 2005 to that in 2008?
Ensure brevity in your answer.  0.54. What is the ratio of the Expenses (% of total expenses) of Australia in 2005 to that in 2008?
Offer a terse response. 0.88. What is the ratio of the Expenses (% of total expenses) in Jordan in 2005 to that in 2008?
Provide a short and direct response. 2.15. What is the ratio of the Expenses (% of total expenses) of Switzerland in 2005 to that in 2008?
Keep it short and to the point. 1.18. What is the ratio of the Expenses (% of total expenses) in Latin America(all income levels) in 2005 to that in 2009?
Your answer should be compact. 0.52. What is the ratio of the Expenses (% of total expenses) of Australia in 2005 to that in 2009?
Make the answer very short. 0.96. What is the ratio of the Expenses (% of total expenses) in Jordan in 2005 to that in 2009?
Give a very brief answer. 7.36. What is the ratio of the Expenses (% of total expenses) in Switzerland in 2005 to that in 2009?
Your answer should be very brief. 1.36. What is the ratio of the Expenses (% of total expenses) in Latin America(all income levels) in 2005 to that in 2010?
Ensure brevity in your answer.  0.49. What is the ratio of the Expenses (% of total expenses) of Australia in 2005 to that in 2010?
Provide a succinct answer. 0.81. What is the ratio of the Expenses (% of total expenses) in Jordan in 2005 to that in 2010?
Offer a terse response. 5.51. What is the ratio of the Expenses (% of total expenses) in Switzerland in 2005 to that in 2010?
Offer a terse response. 0.69. What is the ratio of the Expenses (% of total expenses) of Latin America(all income levels) in 2006 to that in 2007?
Keep it short and to the point. 1.07. What is the ratio of the Expenses (% of total expenses) in Australia in 2006 to that in 2007?
Your answer should be compact. 0.94. What is the ratio of the Expenses (% of total expenses) in Jordan in 2006 to that in 2007?
Offer a very short reply. 0.44. What is the ratio of the Expenses (% of total expenses) of Switzerland in 2006 to that in 2007?
Ensure brevity in your answer.  0.69. What is the ratio of the Expenses (% of total expenses) of Latin America(all income levels) in 2006 to that in 2008?
Keep it short and to the point. 0.89. What is the ratio of the Expenses (% of total expenses) in Australia in 2006 to that in 2008?
Ensure brevity in your answer.  0.96. What is the ratio of the Expenses (% of total expenses) in Jordan in 2006 to that in 2008?
Your answer should be compact. 2.97. What is the ratio of the Expenses (% of total expenses) in Switzerland in 2006 to that in 2008?
Your response must be concise. 1.25. What is the ratio of the Expenses (% of total expenses) in Latin America(all income levels) in 2006 to that in 2009?
Provide a short and direct response. 0.85. What is the ratio of the Expenses (% of total expenses) in Australia in 2006 to that in 2009?
Provide a succinct answer. 1.04. What is the ratio of the Expenses (% of total expenses) of Jordan in 2006 to that in 2009?
Ensure brevity in your answer.  10.17. What is the ratio of the Expenses (% of total expenses) of Switzerland in 2006 to that in 2009?
Make the answer very short. 1.44. What is the ratio of the Expenses (% of total expenses) of Latin America(all income levels) in 2006 to that in 2010?
Your answer should be very brief. 0.81. What is the ratio of the Expenses (% of total expenses) in Australia in 2006 to that in 2010?
Make the answer very short. 0.88. What is the ratio of the Expenses (% of total expenses) of Jordan in 2006 to that in 2010?
Ensure brevity in your answer.  7.61. What is the ratio of the Expenses (% of total expenses) of Switzerland in 2006 to that in 2010?
Ensure brevity in your answer.  0.73. What is the ratio of the Expenses (% of total expenses) in Latin America(all income levels) in 2007 to that in 2008?
Provide a succinct answer. 0.84. What is the ratio of the Expenses (% of total expenses) in Australia in 2007 to that in 2008?
Give a very brief answer. 1.02. What is the ratio of the Expenses (% of total expenses) of Jordan in 2007 to that in 2008?
Provide a short and direct response. 6.71. What is the ratio of the Expenses (% of total expenses) of Switzerland in 2007 to that in 2008?
Your response must be concise. 1.79. What is the ratio of the Expenses (% of total expenses) of Latin America(all income levels) in 2007 to that in 2009?
Offer a very short reply. 0.8. What is the ratio of the Expenses (% of total expenses) of Australia in 2007 to that in 2009?
Provide a succinct answer. 1.1. What is the ratio of the Expenses (% of total expenses) in Jordan in 2007 to that in 2009?
Offer a very short reply. 22.95. What is the ratio of the Expenses (% of total expenses) in Switzerland in 2007 to that in 2009?
Make the answer very short. 2.08. What is the ratio of the Expenses (% of total expenses) of Latin America(all income levels) in 2007 to that in 2010?
Your answer should be very brief. 0.76. What is the ratio of the Expenses (% of total expenses) of Australia in 2007 to that in 2010?
Provide a short and direct response. 0.94. What is the ratio of the Expenses (% of total expenses) in Jordan in 2007 to that in 2010?
Offer a very short reply. 17.18. What is the ratio of the Expenses (% of total expenses) in Switzerland in 2007 to that in 2010?
Offer a terse response. 1.05. What is the ratio of the Expenses (% of total expenses) in Latin America(all income levels) in 2008 to that in 2009?
Keep it short and to the point. 0.95. What is the ratio of the Expenses (% of total expenses) in Australia in 2008 to that in 2009?
Your response must be concise. 1.08. What is the ratio of the Expenses (% of total expenses) of Jordan in 2008 to that in 2009?
Offer a very short reply. 3.42. What is the ratio of the Expenses (% of total expenses) of Switzerland in 2008 to that in 2009?
Your answer should be compact. 1.16. What is the ratio of the Expenses (% of total expenses) in Latin America(all income levels) in 2008 to that in 2010?
Give a very brief answer. 0.91. What is the ratio of the Expenses (% of total expenses) in Australia in 2008 to that in 2010?
Keep it short and to the point. 0.92. What is the ratio of the Expenses (% of total expenses) of Jordan in 2008 to that in 2010?
Make the answer very short. 2.56. What is the ratio of the Expenses (% of total expenses) of Switzerland in 2008 to that in 2010?
Ensure brevity in your answer.  0.58. What is the ratio of the Expenses (% of total expenses) of Latin America(all income levels) in 2009 to that in 2010?
Make the answer very short. 0.95. What is the ratio of the Expenses (% of total expenses) in Australia in 2009 to that in 2010?
Provide a short and direct response. 0.85. What is the ratio of the Expenses (% of total expenses) of Jordan in 2009 to that in 2010?
Ensure brevity in your answer.  0.75. What is the ratio of the Expenses (% of total expenses) in Switzerland in 2009 to that in 2010?
Offer a terse response. 0.5. What is the difference between the highest and the second highest Expenses (% of total expenses) of Latin America(all income levels)?
Give a very brief answer. 0.51. What is the difference between the highest and the second highest Expenses (% of total expenses) in Australia?
Provide a short and direct response. 0.41. What is the difference between the highest and the second highest Expenses (% of total expenses) in Jordan?
Make the answer very short. 19.49. What is the difference between the highest and the second highest Expenses (% of total expenses) of Switzerland?
Your answer should be very brief. 0.27. What is the difference between the highest and the lowest Expenses (% of total expenses) of Latin America(all income levels)?
Your response must be concise. 5.47. What is the difference between the highest and the lowest Expenses (% of total expenses) of Australia?
Your response must be concise. 1.32. What is the difference between the highest and the lowest Expenses (% of total expenses) of Jordan?
Make the answer very short. 33.47. What is the difference between the highest and the lowest Expenses (% of total expenses) in Switzerland?
Your response must be concise. 3.19. 